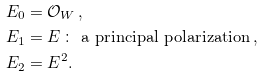<formula> <loc_0><loc_0><loc_500><loc_500>& E _ { 0 } = \mathcal { O } _ { W } \, , \\ & E _ { 1 } = E \, \colon \text { a principal polarization} \, , \\ & E _ { 2 } = E ^ { 2 } .</formula> 